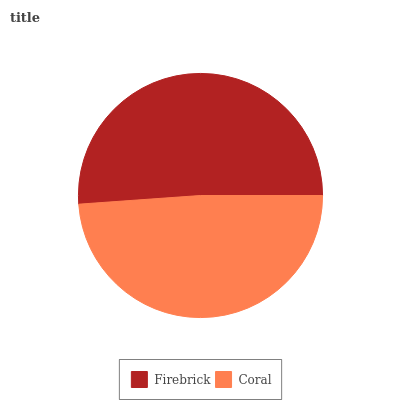Is Coral the minimum?
Answer yes or no. Yes. Is Firebrick the maximum?
Answer yes or no. Yes. Is Coral the maximum?
Answer yes or no. No. Is Firebrick greater than Coral?
Answer yes or no. Yes. Is Coral less than Firebrick?
Answer yes or no. Yes. Is Coral greater than Firebrick?
Answer yes or no. No. Is Firebrick less than Coral?
Answer yes or no. No. Is Firebrick the high median?
Answer yes or no. Yes. Is Coral the low median?
Answer yes or no. Yes. Is Coral the high median?
Answer yes or no. No. Is Firebrick the low median?
Answer yes or no. No. 